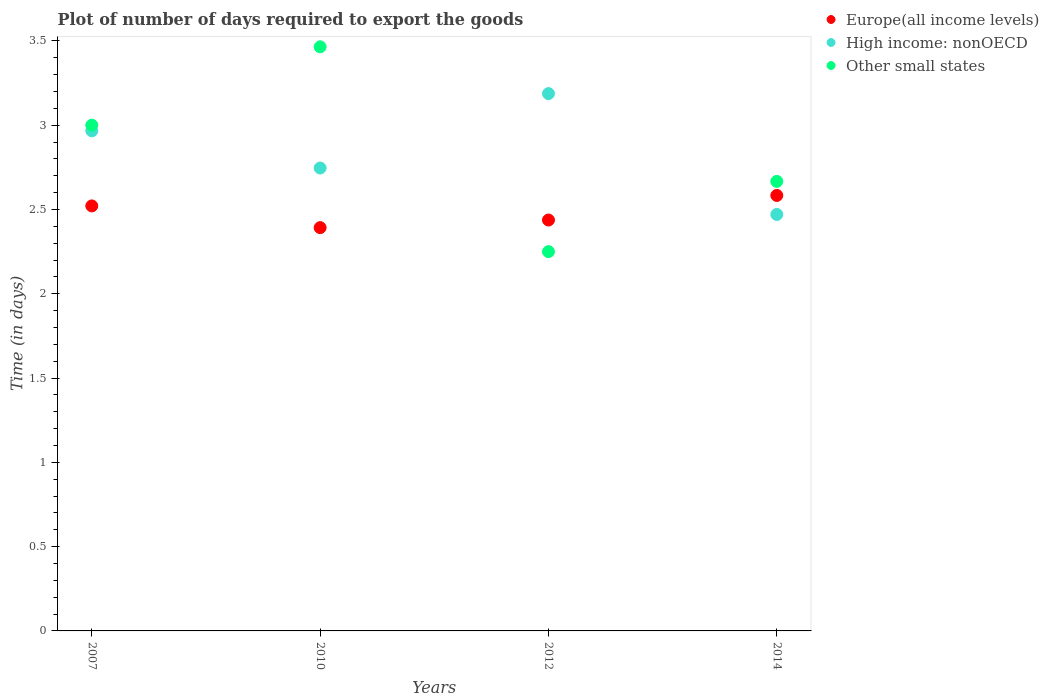How many different coloured dotlines are there?
Provide a short and direct response. 3. Is the number of dotlines equal to the number of legend labels?
Your answer should be very brief. Yes. What is the time required to export goods in Other small states in 2010?
Your answer should be very brief. 3.46. Across all years, what is the maximum time required to export goods in High income: nonOECD?
Your answer should be compact. 3.19. Across all years, what is the minimum time required to export goods in Europe(all income levels)?
Make the answer very short. 2.39. In which year was the time required to export goods in High income: nonOECD maximum?
Your answer should be compact. 2012. What is the total time required to export goods in Europe(all income levels) in the graph?
Make the answer very short. 9.93. What is the difference between the time required to export goods in Other small states in 2007 and that in 2010?
Your response must be concise. -0.46. What is the difference between the time required to export goods in Other small states in 2014 and the time required to export goods in Europe(all income levels) in 2007?
Provide a succinct answer. 0.15. What is the average time required to export goods in Europe(all income levels) per year?
Offer a terse response. 2.48. In the year 2012, what is the difference between the time required to export goods in Other small states and time required to export goods in Europe(all income levels)?
Offer a terse response. -0.19. What is the ratio of the time required to export goods in High income: nonOECD in 2010 to that in 2014?
Ensure brevity in your answer.  1.11. Is the difference between the time required to export goods in Other small states in 2007 and 2010 greater than the difference between the time required to export goods in Europe(all income levels) in 2007 and 2010?
Provide a succinct answer. No. What is the difference between the highest and the second highest time required to export goods in High income: nonOECD?
Your answer should be very brief. 0.22. What is the difference between the highest and the lowest time required to export goods in Europe(all income levels)?
Offer a terse response. 0.19. Is the sum of the time required to export goods in Europe(all income levels) in 2010 and 2014 greater than the maximum time required to export goods in High income: nonOECD across all years?
Provide a succinct answer. Yes. Is it the case that in every year, the sum of the time required to export goods in Other small states and time required to export goods in Europe(all income levels)  is greater than the time required to export goods in High income: nonOECD?
Offer a terse response. Yes. Does the time required to export goods in High income: nonOECD monotonically increase over the years?
Provide a short and direct response. No. Is the time required to export goods in Europe(all income levels) strictly less than the time required to export goods in Other small states over the years?
Offer a terse response. No. How many years are there in the graph?
Offer a terse response. 4. Are the values on the major ticks of Y-axis written in scientific E-notation?
Your response must be concise. No. Does the graph contain grids?
Provide a short and direct response. No. How many legend labels are there?
Provide a succinct answer. 3. How are the legend labels stacked?
Provide a succinct answer. Vertical. What is the title of the graph?
Keep it short and to the point. Plot of number of days required to export the goods. Does "Europe(all income levels)" appear as one of the legend labels in the graph?
Your answer should be very brief. Yes. What is the label or title of the Y-axis?
Provide a short and direct response. Time (in days). What is the Time (in days) in Europe(all income levels) in 2007?
Your answer should be compact. 2.52. What is the Time (in days) of High income: nonOECD in 2007?
Keep it short and to the point. 2.97. What is the Time (in days) of Europe(all income levels) in 2010?
Ensure brevity in your answer.  2.39. What is the Time (in days) in High income: nonOECD in 2010?
Provide a succinct answer. 2.75. What is the Time (in days) in Other small states in 2010?
Offer a terse response. 3.46. What is the Time (in days) of Europe(all income levels) in 2012?
Your answer should be very brief. 2.44. What is the Time (in days) of High income: nonOECD in 2012?
Keep it short and to the point. 3.19. What is the Time (in days) of Other small states in 2012?
Your answer should be compact. 2.25. What is the Time (in days) in Europe(all income levels) in 2014?
Offer a very short reply. 2.58. What is the Time (in days) of High income: nonOECD in 2014?
Offer a terse response. 2.47. What is the Time (in days) of Other small states in 2014?
Keep it short and to the point. 2.67. Across all years, what is the maximum Time (in days) in Europe(all income levels)?
Your answer should be very brief. 2.58. Across all years, what is the maximum Time (in days) of High income: nonOECD?
Your answer should be compact. 3.19. Across all years, what is the maximum Time (in days) in Other small states?
Make the answer very short. 3.46. Across all years, what is the minimum Time (in days) in Europe(all income levels)?
Your response must be concise. 2.39. Across all years, what is the minimum Time (in days) of High income: nonOECD?
Keep it short and to the point. 2.47. Across all years, what is the minimum Time (in days) of Other small states?
Provide a succinct answer. 2.25. What is the total Time (in days) in Europe(all income levels) in the graph?
Keep it short and to the point. 9.93. What is the total Time (in days) of High income: nonOECD in the graph?
Offer a terse response. 11.37. What is the total Time (in days) in Other small states in the graph?
Your answer should be compact. 11.38. What is the difference between the Time (in days) of Europe(all income levels) in 2007 and that in 2010?
Your response must be concise. 0.13. What is the difference between the Time (in days) of High income: nonOECD in 2007 and that in 2010?
Provide a short and direct response. 0.22. What is the difference between the Time (in days) in Other small states in 2007 and that in 2010?
Keep it short and to the point. -0.47. What is the difference between the Time (in days) in Europe(all income levels) in 2007 and that in 2012?
Keep it short and to the point. 0.08. What is the difference between the Time (in days) in High income: nonOECD in 2007 and that in 2012?
Give a very brief answer. -0.22. What is the difference between the Time (in days) in Europe(all income levels) in 2007 and that in 2014?
Offer a terse response. -0.06. What is the difference between the Time (in days) in High income: nonOECD in 2007 and that in 2014?
Your answer should be compact. 0.5. What is the difference between the Time (in days) in Europe(all income levels) in 2010 and that in 2012?
Your answer should be compact. -0.05. What is the difference between the Time (in days) in High income: nonOECD in 2010 and that in 2012?
Your answer should be compact. -0.44. What is the difference between the Time (in days) in Other small states in 2010 and that in 2012?
Ensure brevity in your answer.  1.22. What is the difference between the Time (in days) of Europe(all income levels) in 2010 and that in 2014?
Ensure brevity in your answer.  -0.19. What is the difference between the Time (in days) of High income: nonOECD in 2010 and that in 2014?
Provide a succinct answer. 0.28. What is the difference between the Time (in days) of Other small states in 2010 and that in 2014?
Provide a short and direct response. 0.8. What is the difference between the Time (in days) of Europe(all income levels) in 2012 and that in 2014?
Your response must be concise. -0.15. What is the difference between the Time (in days) of High income: nonOECD in 2012 and that in 2014?
Give a very brief answer. 0.72. What is the difference between the Time (in days) of Other small states in 2012 and that in 2014?
Offer a terse response. -0.42. What is the difference between the Time (in days) in Europe(all income levels) in 2007 and the Time (in days) in High income: nonOECD in 2010?
Ensure brevity in your answer.  -0.22. What is the difference between the Time (in days) in Europe(all income levels) in 2007 and the Time (in days) in Other small states in 2010?
Make the answer very short. -0.94. What is the difference between the Time (in days) of High income: nonOECD in 2007 and the Time (in days) of Other small states in 2010?
Give a very brief answer. -0.5. What is the difference between the Time (in days) in Europe(all income levels) in 2007 and the Time (in days) in High income: nonOECD in 2012?
Provide a succinct answer. -0.67. What is the difference between the Time (in days) of Europe(all income levels) in 2007 and the Time (in days) of Other small states in 2012?
Provide a short and direct response. 0.27. What is the difference between the Time (in days) in High income: nonOECD in 2007 and the Time (in days) in Other small states in 2012?
Offer a very short reply. 0.72. What is the difference between the Time (in days) in Europe(all income levels) in 2007 and the Time (in days) in High income: nonOECD in 2014?
Give a very brief answer. 0.05. What is the difference between the Time (in days) of Europe(all income levels) in 2007 and the Time (in days) of Other small states in 2014?
Ensure brevity in your answer.  -0.15. What is the difference between the Time (in days) in Europe(all income levels) in 2010 and the Time (in days) in High income: nonOECD in 2012?
Your response must be concise. -0.8. What is the difference between the Time (in days) in Europe(all income levels) in 2010 and the Time (in days) in Other small states in 2012?
Give a very brief answer. 0.14. What is the difference between the Time (in days) in High income: nonOECD in 2010 and the Time (in days) in Other small states in 2012?
Your answer should be very brief. 0.5. What is the difference between the Time (in days) in Europe(all income levels) in 2010 and the Time (in days) in High income: nonOECD in 2014?
Your answer should be very brief. -0.08. What is the difference between the Time (in days) of Europe(all income levels) in 2010 and the Time (in days) of Other small states in 2014?
Give a very brief answer. -0.27. What is the difference between the Time (in days) in High income: nonOECD in 2010 and the Time (in days) in Other small states in 2014?
Offer a very short reply. 0.08. What is the difference between the Time (in days) in Europe(all income levels) in 2012 and the Time (in days) in High income: nonOECD in 2014?
Provide a short and direct response. -0.03. What is the difference between the Time (in days) of Europe(all income levels) in 2012 and the Time (in days) of Other small states in 2014?
Your response must be concise. -0.23. What is the difference between the Time (in days) of High income: nonOECD in 2012 and the Time (in days) of Other small states in 2014?
Your answer should be very brief. 0.52. What is the average Time (in days) in Europe(all income levels) per year?
Offer a very short reply. 2.48. What is the average Time (in days) in High income: nonOECD per year?
Your response must be concise. 2.84. What is the average Time (in days) of Other small states per year?
Keep it short and to the point. 2.85. In the year 2007, what is the difference between the Time (in days) of Europe(all income levels) and Time (in days) of High income: nonOECD?
Your answer should be very brief. -0.45. In the year 2007, what is the difference between the Time (in days) in Europe(all income levels) and Time (in days) in Other small states?
Your response must be concise. -0.48. In the year 2007, what is the difference between the Time (in days) of High income: nonOECD and Time (in days) of Other small states?
Offer a very short reply. -0.03. In the year 2010, what is the difference between the Time (in days) of Europe(all income levels) and Time (in days) of High income: nonOECD?
Offer a very short reply. -0.35. In the year 2010, what is the difference between the Time (in days) of Europe(all income levels) and Time (in days) of Other small states?
Give a very brief answer. -1.07. In the year 2010, what is the difference between the Time (in days) of High income: nonOECD and Time (in days) of Other small states?
Offer a very short reply. -0.72. In the year 2012, what is the difference between the Time (in days) of Europe(all income levels) and Time (in days) of High income: nonOECD?
Offer a terse response. -0.75. In the year 2012, what is the difference between the Time (in days) in Europe(all income levels) and Time (in days) in Other small states?
Your answer should be compact. 0.19. In the year 2012, what is the difference between the Time (in days) in High income: nonOECD and Time (in days) in Other small states?
Offer a very short reply. 0.94. In the year 2014, what is the difference between the Time (in days) of Europe(all income levels) and Time (in days) of High income: nonOECD?
Your answer should be compact. 0.11. In the year 2014, what is the difference between the Time (in days) in Europe(all income levels) and Time (in days) in Other small states?
Provide a short and direct response. -0.08. In the year 2014, what is the difference between the Time (in days) in High income: nonOECD and Time (in days) in Other small states?
Provide a short and direct response. -0.2. What is the ratio of the Time (in days) in Europe(all income levels) in 2007 to that in 2010?
Your answer should be very brief. 1.05. What is the ratio of the Time (in days) of High income: nonOECD in 2007 to that in 2010?
Provide a short and direct response. 1.08. What is the ratio of the Time (in days) of Other small states in 2007 to that in 2010?
Provide a succinct answer. 0.87. What is the ratio of the Time (in days) of Europe(all income levels) in 2007 to that in 2012?
Your response must be concise. 1.03. What is the ratio of the Time (in days) of High income: nonOECD in 2007 to that in 2012?
Your answer should be very brief. 0.93. What is the ratio of the Time (in days) of Other small states in 2007 to that in 2012?
Your answer should be very brief. 1.33. What is the ratio of the Time (in days) in Europe(all income levels) in 2007 to that in 2014?
Offer a very short reply. 0.98. What is the ratio of the Time (in days) of High income: nonOECD in 2007 to that in 2014?
Your answer should be very brief. 1.2. What is the ratio of the Time (in days) of Europe(all income levels) in 2010 to that in 2012?
Make the answer very short. 0.98. What is the ratio of the Time (in days) in High income: nonOECD in 2010 to that in 2012?
Offer a very short reply. 0.86. What is the ratio of the Time (in days) of Other small states in 2010 to that in 2012?
Provide a succinct answer. 1.54. What is the ratio of the Time (in days) of Europe(all income levels) in 2010 to that in 2014?
Your response must be concise. 0.93. What is the ratio of the Time (in days) in High income: nonOECD in 2010 to that in 2014?
Make the answer very short. 1.11. What is the ratio of the Time (in days) in Other small states in 2010 to that in 2014?
Your response must be concise. 1.3. What is the ratio of the Time (in days) of Europe(all income levels) in 2012 to that in 2014?
Offer a terse response. 0.94. What is the ratio of the Time (in days) in High income: nonOECD in 2012 to that in 2014?
Ensure brevity in your answer.  1.29. What is the ratio of the Time (in days) of Other small states in 2012 to that in 2014?
Offer a terse response. 0.84. What is the difference between the highest and the second highest Time (in days) of Europe(all income levels)?
Provide a succinct answer. 0.06. What is the difference between the highest and the second highest Time (in days) in High income: nonOECD?
Your answer should be compact. 0.22. What is the difference between the highest and the second highest Time (in days) in Other small states?
Offer a very short reply. 0.47. What is the difference between the highest and the lowest Time (in days) in Europe(all income levels)?
Your response must be concise. 0.19. What is the difference between the highest and the lowest Time (in days) of High income: nonOECD?
Provide a succinct answer. 0.72. What is the difference between the highest and the lowest Time (in days) in Other small states?
Your answer should be very brief. 1.22. 